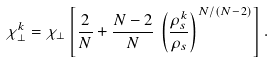<formula> <loc_0><loc_0><loc_500><loc_500>\chi ^ { k } _ { \perp } = \chi _ { \perp } \left [ \frac { 2 } { N } + \frac { N - 2 } { N } \, \left ( \frac { \rho ^ { k } _ { s } } { \rho _ { s } } \right ) ^ { N / ( N - 2 ) } \right ] .</formula> 